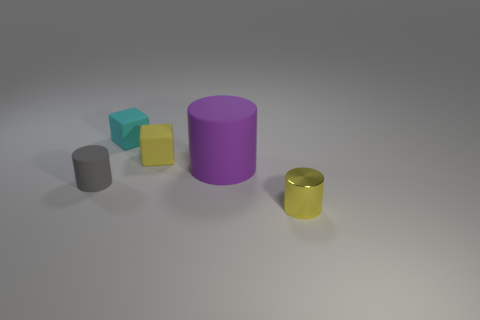Subtract all blue cylinders. Subtract all red spheres. How many cylinders are left? 3 Add 1 large gray metallic cubes. How many objects exist? 6 Subtract all cylinders. How many objects are left? 2 Subtract all large blue metallic cylinders. Subtract all tiny metallic cylinders. How many objects are left? 4 Add 1 tiny yellow blocks. How many tiny yellow blocks are left? 2 Add 1 cylinders. How many cylinders exist? 4 Subtract 0 blue spheres. How many objects are left? 5 